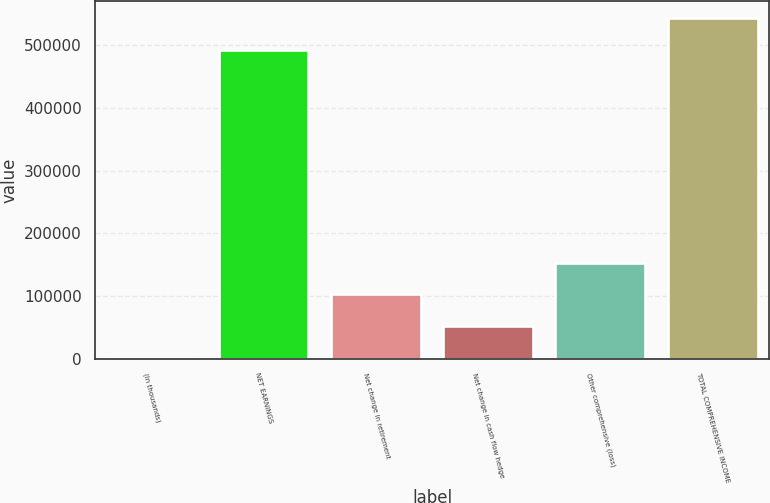<chart> <loc_0><loc_0><loc_500><loc_500><bar_chart><fcel>(In thousands)<fcel>NET EARNINGS<fcel>Net change in retirement<fcel>Net change in cash flow hedge<fcel>Other comprehensive (loss)<fcel>TOTAL COMPREHENSIVE INCOME<nl><fcel>2014<fcel>492586<fcel>102836<fcel>52424.9<fcel>153247<fcel>542997<nl></chart> 